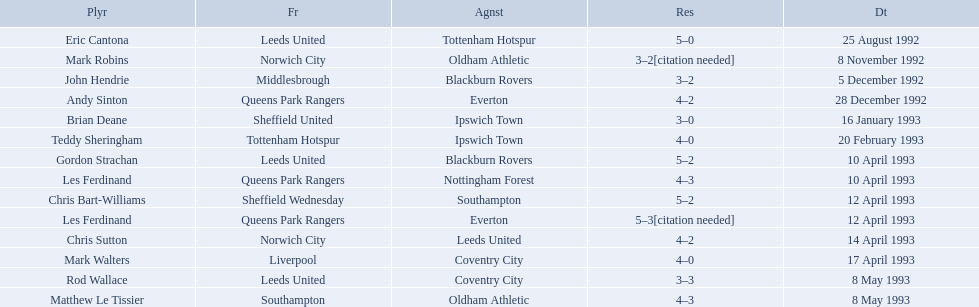What are the results? 5–0, 3–2[citation needed], 3–2, 4–2, 3–0, 4–0, 5–2, 4–3, 5–2, 5–3[citation needed], 4–2, 4–0, 3–3, 4–3. What result did mark robins have? 3–2[citation needed]. What other player had that result? John Hendrie. 